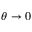Convert formula to latex. <formula><loc_0><loc_0><loc_500><loc_500>\theta \rightarrow 0</formula> 